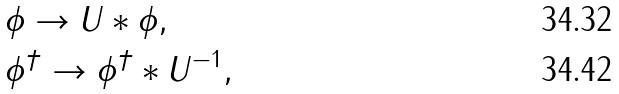Convert formula to latex. <formula><loc_0><loc_0><loc_500><loc_500>& \phi \to U * \phi , \\ & \phi ^ { \dag } \to \phi ^ { \dag } * U ^ { - 1 } ,</formula> 